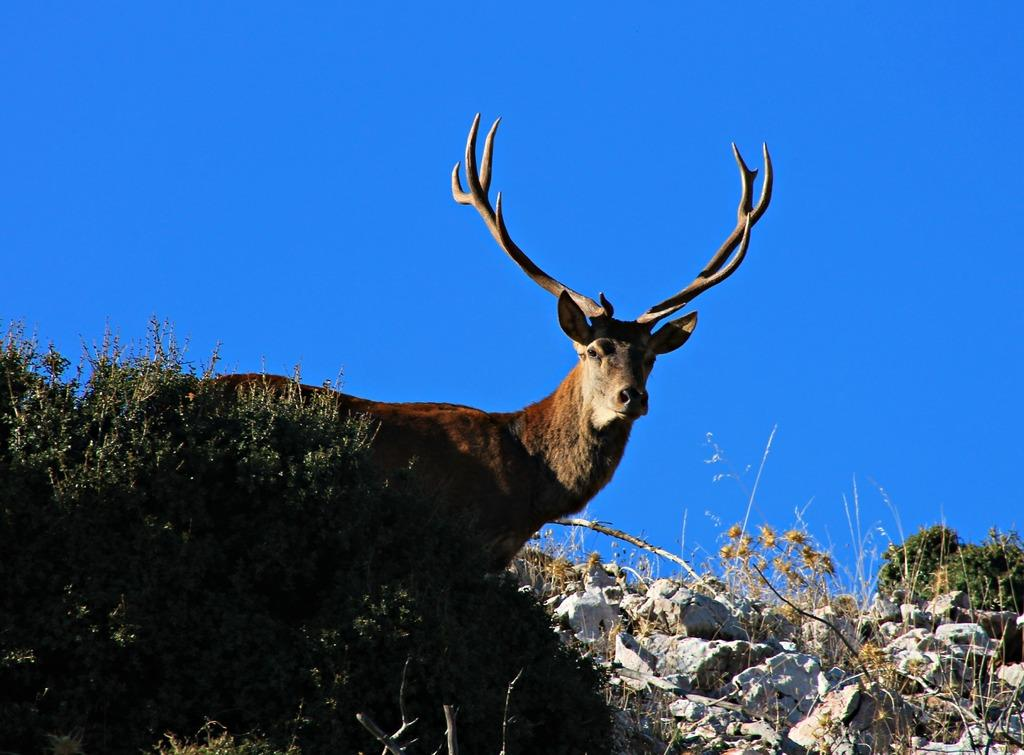What is the main subject in the center of the image? There is an animal in the center of the image. What can be seen at the bottom of the image? There are plants and rocks at the bottom of the image. What is visible at the top of the image? The sky is visible at the top of the image. What type of doll is the governor using to cook in the image? There is no doll, governor, or cooking activity present in the image. 